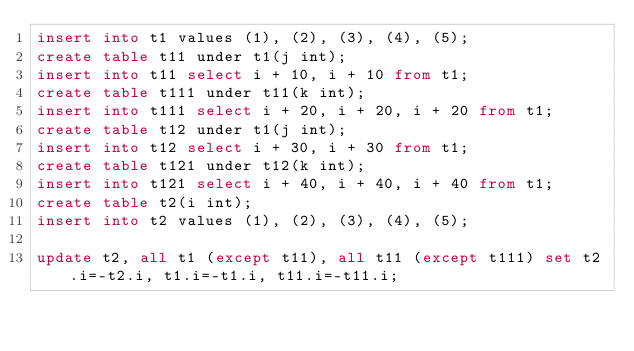Convert code to text. <code><loc_0><loc_0><loc_500><loc_500><_SQL_>insert into t1 values (1), (2), (3), (4), (5);
create table t11 under t1(j int);
insert into t11 select i + 10, i + 10 from t1;
create table t111 under t11(k int);
insert into t111 select i + 20, i + 20, i + 20 from t1;
create table t12 under t1(j int);
insert into t12 select i + 30, i + 30 from t1;
create table t121 under t12(k int);
insert into t121 select i + 40, i + 40, i + 40 from t1;
create table t2(i int);
insert into t2 values (1), (2), (3), (4), (5);

update t2, all t1 (except t11), all t11 (except t111) set t2.i=-t2.i, t1.i=-t1.i, t11.i=-t11.i;</code> 